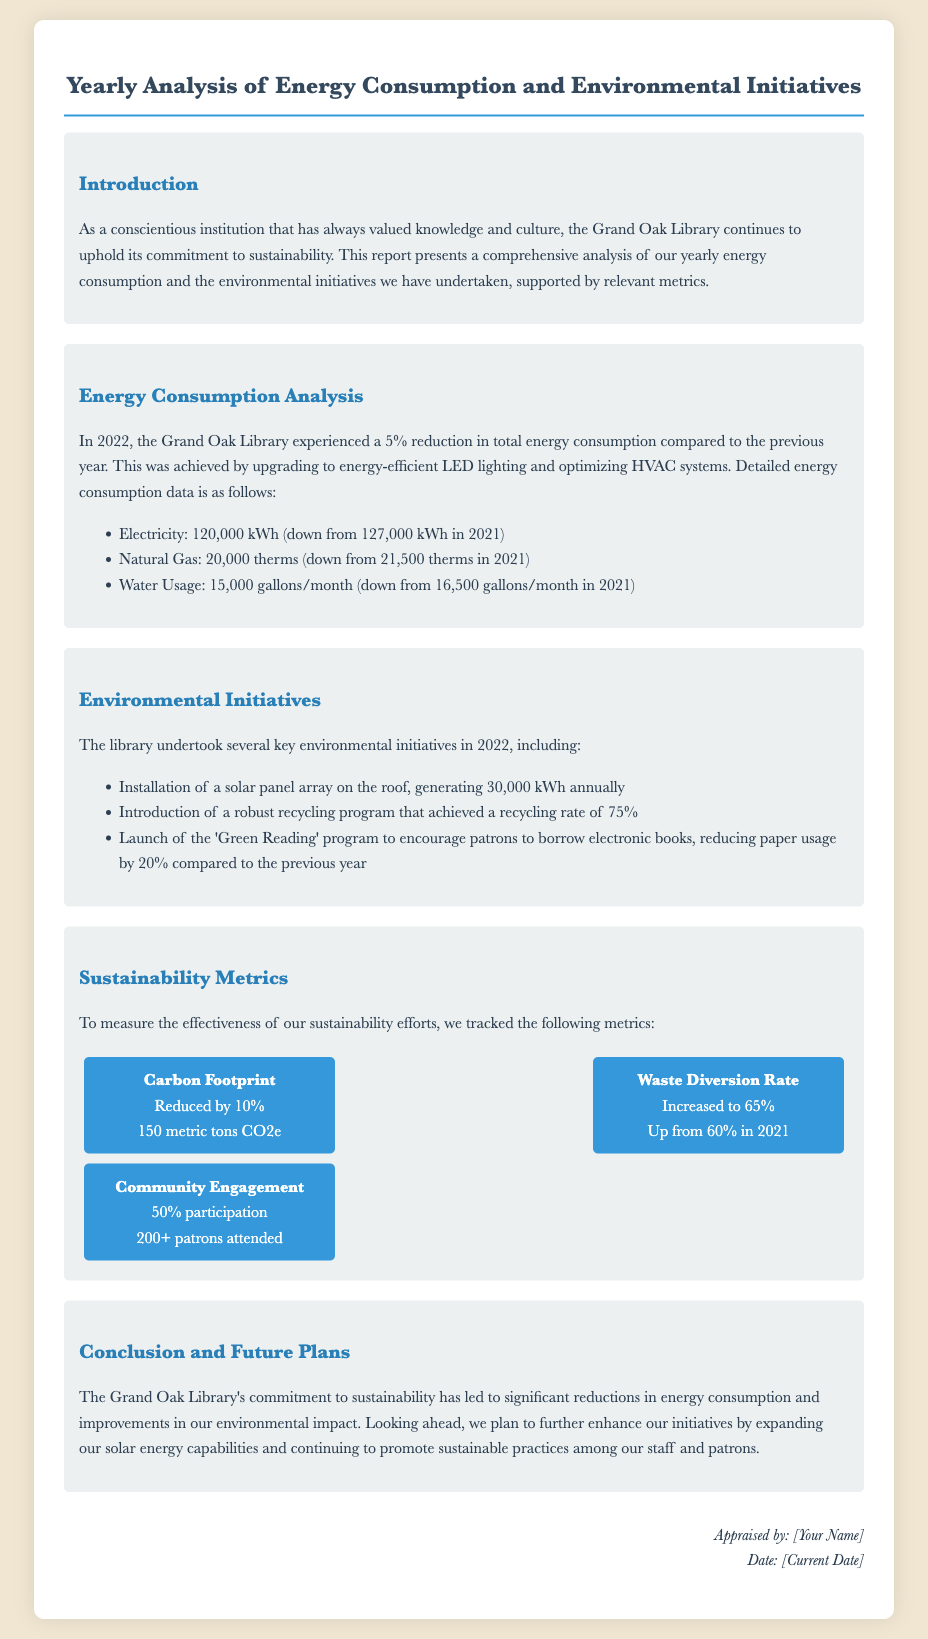what was the percentage reduction in energy consumption? The report states there was a 5% reduction in total energy consumption compared to the previous year.
Answer: 5% how much electricity did the library consume in 2022? The document shows that the library consumed 120,000 kWh of electricity in 2022.
Answer: 120,000 kWh what is the recycling rate achieved by the library's program? The report mentions that the recycling program achieved a recycling rate of 75%.
Answer: 75% how much was the natural gas consumption in 2022? The library consumed 20,000 therms of natural gas in 2022 according to the document.
Answer: 20,000 therms what was the carbon footprint reduction? The document indicates that the carbon footprint was reduced by 10%.
Answer: 10% how many patrons attended the community engagement events? The report states that over 200 patrons attended the community engagement events.
Answer: 200+ what new program was launched to encourage borrowing electronic books? The document mentions the launch of the 'Green Reading' program.
Answer: 'Green Reading' how many gallons of water were used per month in 2022? The library used 15,000 gallons of water per month in 2022 as stated in the document.
Answer: 15,000 gallons/month what are the future plans mentioned for enhancing sustainability initiatives? The document indicates that the library plans to expand solar energy capabilities and promote sustainable practices.
Answer: Expand solar energy capabilities 